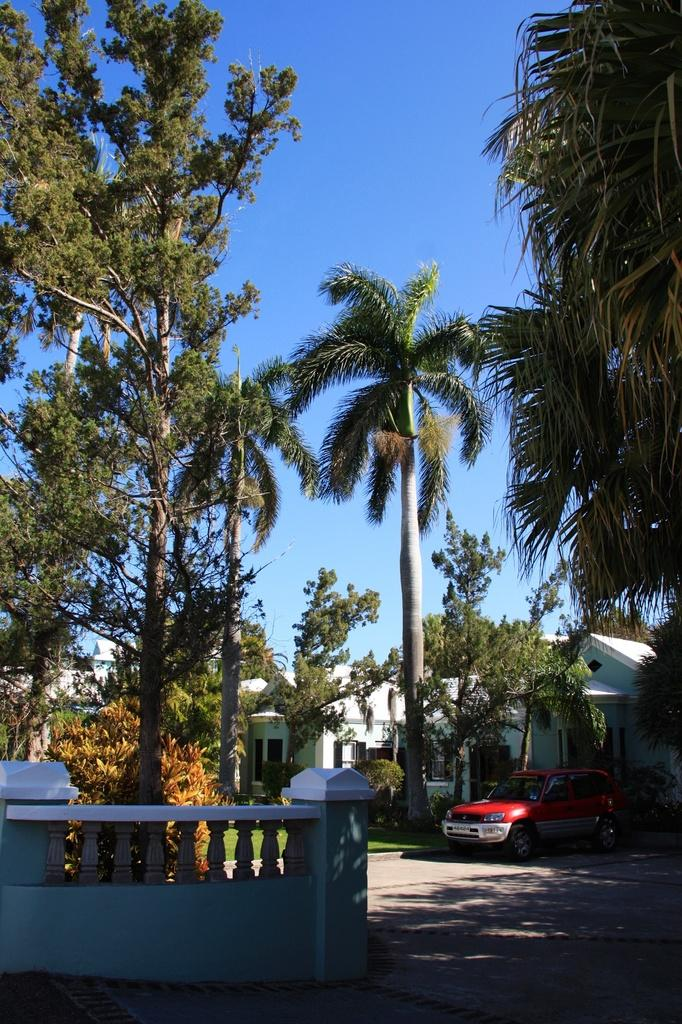What type of structures can be seen in the image? There are houses in the image. What type of vegetation is present in the image? There are trees and grass in the image. What architectural feature can be seen in the image? There is a wall in the image. What can be seen through the windows visible in the image? The windows provide a view of the surrounding environment, including trees, grass, and houses. What type of vehicle is present in the image? There is a vehicle in the image. What is visible in the background of the image? The sky is visible in the background of the image. What position does the bag hold in the image? There is no bag present in the image. What type of work is being done by the people in the image? There are no people visible in the image, so it is impossible to determine what type of work they might be doing. 